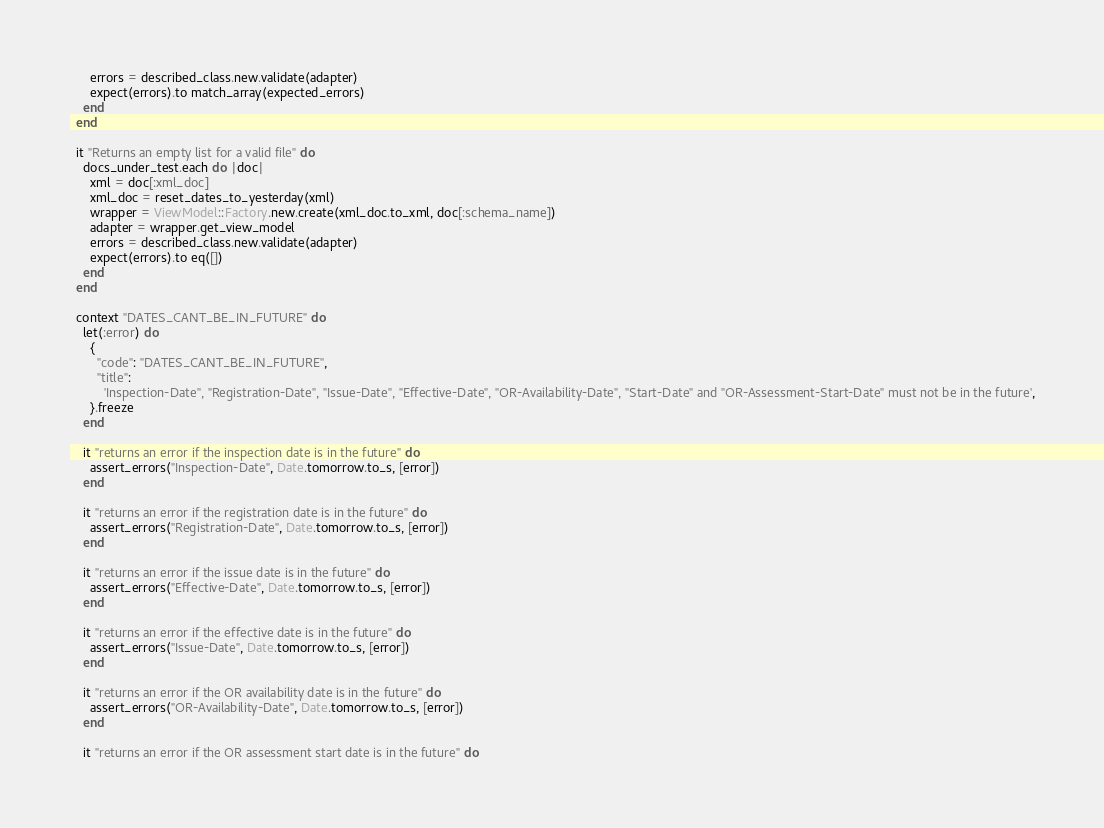Convert code to text. <code><loc_0><loc_0><loc_500><loc_500><_Ruby_>      errors = described_class.new.validate(adapter)
      expect(errors).to match_array(expected_errors)
    end
  end

  it "Returns an empty list for a valid file" do
    docs_under_test.each do |doc|
      xml = doc[:xml_doc]
      xml_doc = reset_dates_to_yesterday(xml)
      wrapper = ViewModel::Factory.new.create(xml_doc.to_xml, doc[:schema_name])
      adapter = wrapper.get_view_model
      errors = described_class.new.validate(adapter)
      expect(errors).to eq([])
    end
  end

  context "DATES_CANT_BE_IN_FUTURE" do
    let(:error) do
      {
        "code": "DATES_CANT_BE_IN_FUTURE",
        "title":
          'Inspection-Date", "Registration-Date", "Issue-Date", "Effective-Date", "OR-Availability-Date", "Start-Date" and "OR-Assessment-Start-Date" must not be in the future',
      }.freeze
    end

    it "returns an error if the inspection date is in the future" do
      assert_errors("Inspection-Date", Date.tomorrow.to_s, [error])
    end

    it "returns an error if the registration date is in the future" do
      assert_errors("Registration-Date", Date.tomorrow.to_s, [error])
    end

    it "returns an error if the issue date is in the future" do
      assert_errors("Effective-Date", Date.tomorrow.to_s, [error])
    end

    it "returns an error if the effective date is in the future" do
      assert_errors("Issue-Date", Date.tomorrow.to_s, [error])
    end

    it "returns an error if the OR availability date is in the future" do
      assert_errors("OR-Availability-Date", Date.tomorrow.to_s, [error])
    end

    it "returns an error if the OR assessment start date is in the future" do</code> 